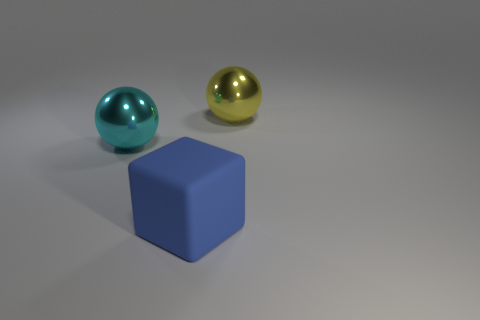Can you describe the lighting in the scene and how it affects the appearance of the objects? The lighting in the scene appears to be uniformly diffused, coming from above, casting soft shadows beneath the objects. It highlights the curvature of the spheres and emphasizes the geometric shape of the cube, creating a calm and balanced visual appearance. 